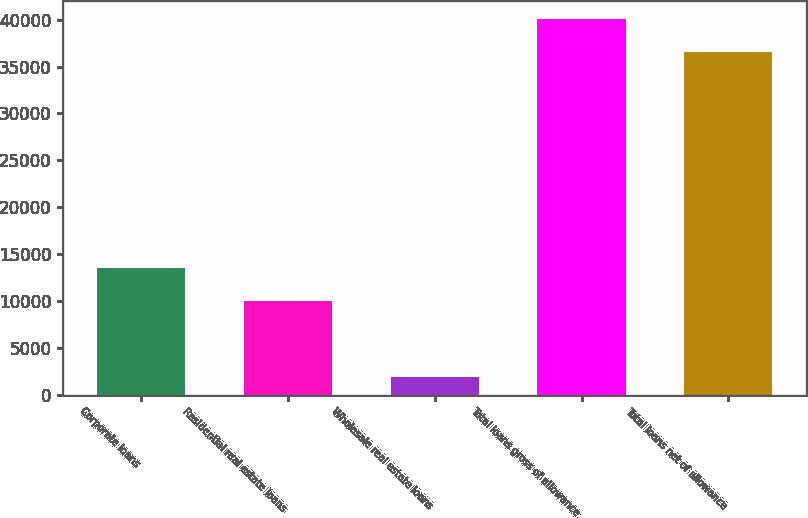Convert chart to OTSL. <chart><loc_0><loc_0><loc_500><loc_500><bar_chart><fcel>Corporate loans<fcel>Residential real estate loans<fcel>Wholesale real estate loans<fcel>Total loans gross of allowance<fcel>Total loans net of allowance<nl><fcel>13490.6<fcel>10006<fcel>1855<fcel>40029.6<fcel>36545<nl></chart> 